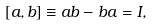Convert formula to latex. <formula><loc_0><loc_0><loc_500><loc_500>[ a , b ] \equiv a b - b a = I ,</formula> 